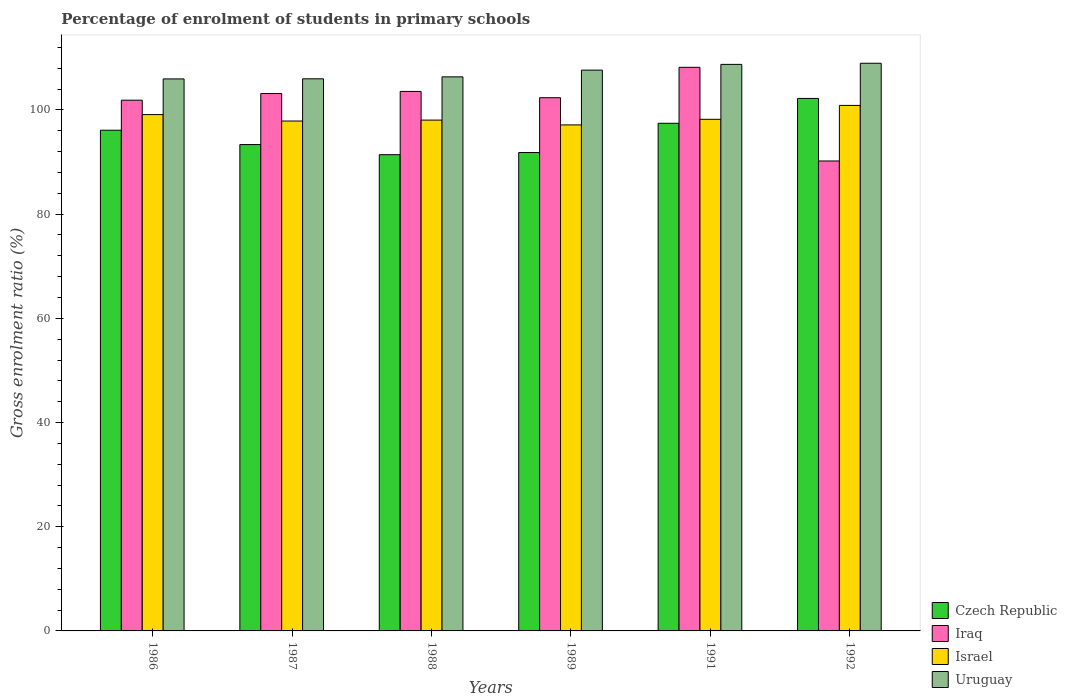How many different coloured bars are there?
Provide a succinct answer. 4. How many groups of bars are there?
Ensure brevity in your answer.  6. How many bars are there on the 5th tick from the left?
Provide a short and direct response. 4. How many bars are there on the 6th tick from the right?
Provide a short and direct response. 4. What is the label of the 2nd group of bars from the left?
Ensure brevity in your answer.  1987. In how many cases, is the number of bars for a given year not equal to the number of legend labels?
Offer a terse response. 0. What is the percentage of students enrolled in primary schools in Uruguay in 1987?
Offer a very short reply. 105.98. Across all years, what is the maximum percentage of students enrolled in primary schools in Uruguay?
Offer a terse response. 108.96. Across all years, what is the minimum percentage of students enrolled in primary schools in Uruguay?
Your response must be concise. 105.96. What is the total percentage of students enrolled in primary schools in Iraq in the graph?
Provide a short and direct response. 609.33. What is the difference between the percentage of students enrolled in primary schools in Iraq in 1986 and that in 1991?
Your response must be concise. -6.31. What is the difference between the percentage of students enrolled in primary schools in Israel in 1986 and the percentage of students enrolled in primary schools in Uruguay in 1989?
Make the answer very short. -8.53. What is the average percentage of students enrolled in primary schools in Uruguay per year?
Your answer should be compact. 107.28. In the year 1986, what is the difference between the percentage of students enrolled in primary schools in Iraq and percentage of students enrolled in primary schools in Czech Republic?
Your answer should be very brief. 5.76. In how many years, is the percentage of students enrolled in primary schools in Israel greater than 76 %?
Provide a short and direct response. 6. What is the ratio of the percentage of students enrolled in primary schools in Uruguay in 1988 to that in 1989?
Keep it short and to the point. 0.99. Is the difference between the percentage of students enrolled in primary schools in Iraq in 1987 and 1988 greater than the difference between the percentage of students enrolled in primary schools in Czech Republic in 1987 and 1988?
Provide a short and direct response. No. What is the difference between the highest and the second highest percentage of students enrolled in primary schools in Israel?
Offer a terse response. 1.76. What is the difference between the highest and the lowest percentage of students enrolled in primary schools in Iraq?
Offer a terse response. 17.98. Is it the case that in every year, the sum of the percentage of students enrolled in primary schools in Iraq and percentage of students enrolled in primary schools in Israel is greater than the sum of percentage of students enrolled in primary schools in Czech Republic and percentage of students enrolled in primary schools in Uruguay?
Make the answer very short. Yes. What does the 2nd bar from the right in 1986 represents?
Make the answer very short. Israel. Is it the case that in every year, the sum of the percentage of students enrolled in primary schools in Uruguay and percentage of students enrolled in primary schools in Iraq is greater than the percentage of students enrolled in primary schools in Israel?
Offer a very short reply. Yes. Are the values on the major ticks of Y-axis written in scientific E-notation?
Provide a succinct answer. No. Does the graph contain any zero values?
Offer a very short reply. No. How are the legend labels stacked?
Offer a very short reply. Vertical. What is the title of the graph?
Offer a terse response. Percentage of enrolment of students in primary schools. Does "Sri Lanka" appear as one of the legend labels in the graph?
Make the answer very short. No. What is the label or title of the X-axis?
Offer a terse response. Years. What is the label or title of the Y-axis?
Provide a succinct answer. Gross enrolment ratio (%). What is the Gross enrolment ratio (%) in Czech Republic in 1986?
Your response must be concise. 96.11. What is the Gross enrolment ratio (%) of Iraq in 1986?
Provide a succinct answer. 101.87. What is the Gross enrolment ratio (%) of Israel in 1986?
Ensure brevity in your answer.  99.11. What is the Gross enrolment ratio (%) of Uruguay in 1986?
Your answer should be compact. 105.96. What is the Gross enrolment ratio (%) in Czech Republic in 1987?
Offer a terse response. 93.36. What is the Gross enrolment ratio (%) of Iraq in 1987?
Provide a succinct answer. 103.16. What is the Gross enrolment ratio (%) of Israel in 1987?
Provide a short and direct response. 97.88. What is the Gross enrolment ratio (%) in Uruguay in 1987?
Your answer should be compact. 105.98. What is the Gross enrolment ratio (%) of Czech Republic in 1988?
Make the answer very short. 91.42. What is the Gross enrolment ratio (%) of Iraq in 1988?
Keep it short and to the point. 103.56. What is the Gross enrolment ratio (%) in Israel in 1988?
Make the answer very short. 98.05. What is the Gross enrolment ratio (%) in Uruguay in 1988?
Provide a short and direct response. 106.35. What is the Gross enrolment ratio (%) of Czech Republic in 1989?
Offer a very short reply. 91.83. What is the Gross enrolment ratio (%) of Iraq in 1989?
Your response must be concise. 102.35. What is the Gross enrolment ratio (%) of Israel in 1989?
Provide a succinct answer. 97.13. What is the Gross enrolment ratio (%) in Uruguay in 1989?
Offer a very short reply. 107.64. What is the Gross enrolment ratio (%) in Czech Republic in 1991?
Your answer should be very brief. 97.44. What is the Gross enrolment ratio (%) in Iraq in 1991?
Offer a terse response. 108.19. What is the Gross enrolment ratio (%) in Israel in 1991?
Make the answer very short. 98.21. What is the Gross enrolment ratio (%) in Uruguay in 1991?
Ensure brevity in your answer.  108.75. What is the Gross enrolment ratio (%) in Czech Republic in 1992?
Give a very brief answer. 102.21. What is the Gross enrolment ratio (%) of Iraq in 1992?
Keep it short and to the point. 90.21. What is the Gross enrolment ratio (%) in Israel in 1992?
Your response must be concise. 100.87. What is the Gross enrolment ratio (%) of Uruguay in 1992?
Keep it short and to the point. 108.96. Across all years, what is the maximum Gross enrolment ratio (%) of Czech Republic?
Keep it short and to the point. 102.21. Across all years, what is the maximum Gross enrolment ratio (%) of Iraq?
Offer a terse response. 108.19. Across all years, what is the maximum Gross enrolment ratio (%) in Israel?
Offer a terse response. 100.87. Across all years, what is the maximum Gross enrolment ratio (%) of Uruguay?
Give a very brief answer. 108.96. Across all years, what is the minimum Gross enrolment ratio (%) of Czech Republic?
Make the answer very short. 91.42. Across all years, what is the minimum Gross enrolment ratio (%) of Iraq?
Your response must be concise. 90.21. Across all years, what is the minimum Gross enrolment ratio (%) in Israel?
Provide a short and direct response. 97.13. Across all years, what is the minimum Gross enrolment ratio (%) of Uruguay?
Make the answer very short. 105.96. What is the total Gross enrolment ratio (%) of Czech Republic in the graph?
Your answer should be compact. 572.36. What is the total Gross enrolment ratio (%) in Iraq in the graph?
Give a very brief answer. 609.33. What is the total Gross enrolment ratio (%) of Israel in the graph?
Offer a very short reply. 591.25. What is the total Gross enrolment ratio (%) in Uruguay in the graph?
Your response must be concise. 643.65. What is the difference between the Gross enrolment ratio (%) in Czech Republic in 1986 and that in 1987?
Your answer should be very brief. 2.75. What is the difference between the Gross enrolment ratio (%) in Iraq in 1986 and that in 1987?
Your response must be concise. -1.28. What is the difference between the Gross enrolment ratio (%) in Israel in 1986 and that in 1987?
Ensure brevity in your answer.  1.23. What is the difference between the Gross enrolment ratio (%) in Uruguay in 1986 and that in 1987?
Your answer should be compact. -0.02. What is the difference between the Gross enrolment ratio (%) of Czech Republic in 1986 and that in 1988?
Provide a succinct answer. 4.69. What is the difference between the Gross enrolment ratio (%) of Iraq in 1986 and that in 1988?
Ensure brevity in your answer.  -1.68. What is the difference between the Gross enrolment ratio (%) of Israel in 1986 and that in 1988?
Make the answer very short. 1.06. What is the difference between the Gross enrolment ratio (%) in Uruguay in 1986 and that in 1988?
Provide a succinct answer. -0.39. What is the difference between the Gross enrolment ratio (%) of Czech Republic in 1986 and that in 1989?
Keep it short and to the point. 4.28. What is the difference between the Gross enrolment ratio (%) in Iraq in 1986 and that in 1989?
Your answer should be compact. -0.48. What is the difference between the Gross enrolment ratio (%) in Israel in 1986 and that in 1989?
Keep it short and to the point. 1.98. What is the difference between the Gross enrolment ratio (%) in Uruguay in 1986 and that in 1989?
Give a very brief answer. -1.68. What is the difference between the Gross enrolment ratio (%) in Czech Republic in 1986 and that in 1991?
Provide a succinct answer. -1.33. What is the difference between the Gross enrolment ratio (%) in Iraq in 1986 and that in 1991?
Your answer should be compact. -6.31. What is the difference between the Gross enrolment ratio (%) of Israel in 1986 and that in 1991?
Keep it short and to the point. 0.9. What is the difference between the Gross enrolment ratio (%) in Uruguay in 1986 and that in 1991?
Your response must be concise. -2.79. What is the difference between the Gross enrolment ratio (%) in Czech Republic in 1986 and that in 1992?
Your answer should be very brief. -6.1. What is the difference between the Gross enrolment ratio (%) of Iraq in 1986 and that in 1992?
Ensure brevity in your answer.  11.67. What is the difference between the Gross enrolment ratio (%) in Israel in 1986 and that in 1992?
Your answer should be very brief. -1.76. What is the difference between the Gross enrolment ratio (%) of Uruguay in 1986 and that in 1992?
Give a very brief answer. -3. What is the difference between the Gross enrolment ratio (%) of Czech Republic in 1987 and that in 1988?
Provide a succinct answer. 1.94. What is the difference between the Gross enrolment ratio (%) in Iraq in 1987 and that in 1988?
Give a very brief answer. -0.4. What is the difference between the Gross enrolment ratio (%) in Israel in 1987 and that in 1988?
Give a very brief answer. -0.18. What is the difference between the Gross enrolment ratio (%) of Uruguay in 1987 and that in 1988?
Give a very brief answer. -0.37. What is the difference between the Gross enrolment ratio (%) in Czech Republic in 1987 and that in 1989?
Ensure brevity in your answer.  1.53. What is the difference between the Gross enrolment ratio (%) of Iraq in 1987 and that in 1989?
Your response must be concise. 0.8. What is the difference between the Gross enrolment ratio (%) of Israel in 1987 and that in 1989?
Your answer should be compact. 0.75. What is the difference between the Gross enrolment ratio (%) of Uruguay in 1987 and that in 1989?
Make the answer very short. -1.66. What is the difference between the Gross enrolment ratio (%) in Czech Republic in 1987 and that in 1991?
Provide a succinct answer. -4.08. What is the difference between the Gross enrolment ratio (%) of Iraq in 1987 and that in 1991?
Make the answer very short. -5.03. What is the difference between the Gross enrolment ratio (%) in Israel in 1987 and that in 1991?
Provide a short and direct response. -0.33. What is the difference between the Gross enrolment ratio (%) of Uruguay in 1987 and that in 1991?
Give a very brief answer. -2.77. What is the difference between the Gross enrolment ratio (%) of Czech Republic in 1987 and that in 1992?
Offer a very short reply. -8.85. What is the difference between the Gross enrolment ratio (%) of Iraq in 1987 and that in 1992?
Provide a succinct answer. 12.95. What is the difference between the Gross enrolment ratio (%) in Israel in 1987 and that in 1992?
Make the answer very short. -2.99. What is the difference between the Gross enrolment ratio (%) of Uruguay in 1987 and that in 1992?
Your response must be concise. -2.98. What is the difference between the Gross enrolment ratio (%) of Czech Republic in 1988 and that in 1989?
Offer a terse response. -0.41. What is the difference between the Gross enrolment ratio (%) in Iraq in 1988 and that in 1989?
Provide a short and direct response. 1.2. What is the difference between the Gross enrolment ratio (%) of Israel in 1988 and that in 1989?
Your response must be concise. 0.92. What is the difference between the Gross enrolment ratio (%) in Uruguay in 1988 and that in 1989?
Provide a succinct answer. -1.29. What is the difference between the Gross enrolment ratio (%) of Czech Republic in 1988 and that in 1991?
Ensure brevity in your answer.  -6.03. What is the difference between the Gross enrolment ratio (%) of Iraq in 1988 and that in 1991?
Provide a succinct answer. -4.63. What is the difference between the Gross enrolment ratio (%) of Israel in 1988 and that in 1991?
Your response must be concise. -0.15. What is the difference between the Gross enrolment ratio (%) in Uruguay in 1988 and that in 1991?
Your answer should be compact. -2.4. What is the difference between the Gross enrolment ratio (%) of Czech Republic in 1988 and that in 1992?
Offer a very short reply. -10.8. What is the difference between the Gross enrolment ratio (%) of Iraq in 1988 and that in 1992?
Offer a very short reply. 13.35. What is the difference between the Gross enrolment ratio (%) in Israel in 1988 and that in 1992?
Make the answer very short. -2.82. What is the difference between the Gross enrolment ratio (%) in Uruguay in 1988 and that in 1992?
Give a very brief answer. -2.61. What is the difference between the Gross enrolment ratio (%) in Czech Republic in 1989 and that in 1991?
Make the answer very short. -5.61. What is the difference between the Gross enrolment ratio (%) of Iraq in 1989 and that in 1991?
Make the answer very short. -5.83. What is the difference between the Gross enrolment ratio (%) of Israel in 1989 and that in 1991?
Your response must be concise. -1.08. What is the difference between the Gross enrolment ratio (%) of Uruguay in 1989 and that in 1991?
Give a very brief answer. -1.1. What is the difference between the Gross enrolment ratio (%) of Czech Republic in 1989 and that in 1992?
Make the answer very short. -10.38. What is the difference between the Gross enrolment ratio (%) of Iraq in 1989 and that in 1992?
Make the answer very short. 12.15. What is the difference between the Gross enrolment ratio (%) in Israel in 1989 and that in 1992?
Your answer should be compact. -3.74. What is the difference between the Gross enrolment ratio (%) of Uruguay in 1989 and that in 1992?
Offer a terse response. -1.32. What is the difference between the Gross enrolment ratio (%) in Czech Republic in 1991 and that in 1992?
Make the answer very short. -4.77. What is the difference between the Gross enrolment ratio (%) in Iraq in 1991 and that in 1992?
Your response must be concise. 17.98. What is the difference between the Gross enrolment ratio (%) of Israel in 1991 and that in 1992?
Provide a short and direct response. -2.67. What is the difference between the Gross enrolment ratio (%) in Uruguay in 1991 and that in 1992?
Provide a succinct answer. -0.22. What is the difference between the Gross enrolment ratio (%) in Czech Republic in 1986 and the Gross enrolment ratio (%) in Iraq in 1987?
Provide a succinct answer. -7.05. What is the difference between the Gross enrolment ratio (%) of Czech Republic in 1986 and the Gross enrolment ratio (%) of Israel in 1987?
Keep it short and to the point. -1.77. What is the difference between the Gross enrolment ratio (%) of Czech Republic in 1986 and the Gross enrolment ratio (%) of Uruguay in 1987?
Your answer should be very brief. -9.87. What is the difference between the Gross enrolment ratio (%) of Iraq in 1986 and the Gross enrolment ratio (%) of Israel in 1987?
Provide a succinct answer. 4. What is the difference between the Gross enrolment ratio (%) of Iraq in 1986 and the Gross enrolment ratio (%) of Uruguay in 1987?
Keep it short and to the point. -4.11. What is the difference between the Gross enrolment ratio (%) of Israel in 1986 and the Gross enrolment ratio (%) of Uruguay in 1987?
Make the answer very short. -6.87. What is the difference between the Gross enrolment ratio (%) in Czech Republic in 1986 and the Gross enrolment ratio (%) in Iraq in 1988?
Offer a very short reply. -7.45. What is the difference between the Gross enrolment ratio (%) in Czech Republic in 1986 and the Gross enrolment ratio (%) in Israel in 1988?
Offer a very short reply. -1.94. What is the difference between the Gross enrolment ratio (%) in Czech Republic in 1986 and the Gross enrolment ratio (%) in Uruguay in 1988?
Offer a terse response. -10.24. What is the difference between the Gross enrolment ratio (%) in Iraq in 1986 and the Gross enrolment ratio (%) in Israel in 1988?
Offer a very short reply. 3.82. What is the difference between the Gross enrolment ratio (%) of Iraq in 1986 and the Gross enrolment ratio (%) of Uruguay in 1988?
Make the answer very short. -4.48. What is the difference between the Gross enrolment ratio (%) in Israel in 1986 and the Gross enrolment ratio (%) in Uruguay in 1988?
Keep it short and to the point. -7.24. What is the difference between the Gross enrolment ratio (%) of Czech Republic in 1986 and the Gross enrolment ratio (%) of Iraq in 1989?
Provide a short and direct response. -6.24. What is the difference between the Gross enrolment ratio (%) of Czech Republic in 1986 and the Gross enrolment ratio (%) of Israel in 1989?
Your answer should be very brief. -1.02. What is the difference between the Gross enrolment ratio (%) in Czech Republic in 1986 and the Gross enrolment ratio (%) in Uruguay in 1989?
Ensure brevity in your answer.  -11.54. What is the difference between the Gross enrolment ratio (%) in Iraq in 1986 and the Gross enrolment ratio (%) in Israel in 1989?
Provide a short and direct response. 4.74. What is the difference between the Gross enrolment ratio (%) of Iraq in 1986 and the Gross enrolment ratio (%) of Uruguay in 1989?
Ensure brevity in your answer.  -5.77. What is the difference between the Gross enrolment ratio (%) in Israel in 1986 and the Gross enrolment ratio (%) in Uruguay in 1989?
Ensure brevity in your answer.  -8.53. What is the difference between the Gross enrolment ratio (%) in Czech Republic in 1986 and the Gross enrolment ratio (%) in Iraq in 1991?
Your answer should be very brief. -12.08. What is the difference between the Gross enrolment ratio (%) of Czech Republic in 1986 and the Gross enrolment ratio (%) of Israel in 1991?
Keep it short and to the point. -2.1. What is the difference between the Gross enrolment ratio (%) in Czech Republic in 1986 and the Gross enrolment ratio (%) in Uruguay in 1991?
Make the answer very short. -12.64. What is the difference between the Gross enrolment ratio (%) in Iraq in 1986 and the Gross enrolment ratio (%) in Israel in 1991?
Offer a terse response. 3.67. What is the difference between the Gross enrolment ratio (%) of Iraq in 1986 and the Gross enrolment ratio (%) of Uruguay in 1991?
Provide a short and direct response. -6.88. What is the difference between the Gross enrolment ratio (%) in Israel in 1986 and the Gross enrolment ratio (%) in Uruguay in 1991?
Make the answer very short. -9.64. What is the difference between the Gross enrolment ratio (%) of Czech Republic in 1986 and the Gross enrolment ratio (%) of Iraq in 1992?
Give a very brief answer. 5.9. What is the difference between the Gross enrolment ratio (%) of Czech Republic in 1986 and the Gross enrolment ratio (%) of Israel in 1992?
Provide a succinct answer. -4.76. What is the difference between the Gross enrolment ratio (%) in Czech Republic in 1986 and the Gross enrolment ratio (%) in Uruguay in 1992?
Your answer should be very brief. -12.86. What is the difference between the Gross enrolment ratio (%) in Iraq in 1986 and the Gross enrolment ratio (%) in Uruguay in 1992?
Your response must be concise. -7.09. What is the difference between the Gross enrolment ratio (%) of Israel in 1986 and the Gross enrolment ratio (%) of Uruguay in 1992?
Make the answer very short. -9.85. What is the difference between the Gross enrolment ratio (%) of Czech Republic in 1987 and the Gross enrolment ratio (%) of Iraq in 1988?
Offer a terse response. -10.2. What is the difference between the Gross enrolment ratio (%) in Czech Republic in 1987 and the Gross enrolment ratio (%) in Israel in 1988?
Your answer should be compact. -4.7. What is the difference between the Gross enrolment ratio (%) in Czech Republic in 1987 and the Gross enrolment ratio (%) in Uruguay in 1988?
Offer a terse response. -12.99. What is the difference between the Gross enrolment ratio (%) of Iraq in 1987 and the Gross enrolment ratio (%) of Israel in 1988?
Provide a short and direct response. 5.1. What is the difference between the Gross enrolment ratio (%) in Iraq in 1987 and the Gross enrolment ratio (%) in Uruguay in 1988?
Your answer should be compact. -3.2. What is the difference between the Gross enrolment ratio (%) in Israel in 1987 and the Gross enrolment ratio (%) in Uruguay in 1988?
Keep it short and to the point. -8.47. What is the difference between the Gross enrolment ratio (%) of Czech Republic in 1987 and the Gross enrolment ratio (%) of Iraq in 1989?
Keep it short and to the point. -8.99. What is the difference between the Gross enrolment ratio (%) of Czech Republic in 1987 and the Gross enrolment ratio (%) of Israel in 1989?
Your response must be concise. -3.77. What is the difference between the Gross enrolment ratio (%) of Czech Republic in 1987 and the Gross enrolment ratio (%) of Uruguay in 1989?
Offer a terse response. -14.29. What is the difference between the Gross enrolment ratio (%) in Iraq in 1987 and the Gross enrolment ratio (%) in Israel in 1989?
Give a very brief answer. 6.03. What is the difference between the Gross enrolment ratio (%) of Iraq in 1987 and the Gross enrolment ratio (%) of Uruguay in 1989?
Your response must be concise. -4.49. What is the difference between the Gross enrolment ratio (%) in Israel in 1987 and the Gross enrolment ratio (%) in Uruguay in 1989?
Offer a terse response. -9.77. What is the difference between the Gross enrolment ratio (%) in Czech Republic in 1987 and the Gross enrolment ratio (%) in Iraq in 1991?
Your response must be concise. -14.83. What is the difference between the Gross enrolment ratio (%) of Czech Republic in 1987 and the Gross enrolment ratio (%) of Israel in 1991?
Ensure brevity in your answer.  -4.85. What is the difference between the Gross enrolment ratio (%) in Czech Republic in 1987 and the Gross enrolment ratio (%) in Uruguay in 1991?
Ensure brevity in your answer.  -15.39. What is the difference between the Gross enrolment ratio (%) in Iraq in 1987 and the Gross enrolment ratio (%) in Israel in 1991?
Offer a very short reply. 4.95. What is the difference between the Gross enrolment ratio (%) of Iraq in 1987 and the Gross enrolment ratio (%) of Uruguay in 1991?
Offer a terse response. -5.59. What is the difference between the Gross enrolment ratio (%) of Israel in 1987 and the Gross enrolment ratio (%) of Uruguay in 1991?
Provide a short and direct response. -10.87. What is the difference between the Gross enrolment ratio (%) in Czech Republic in 1987 and the Gross enrolment ratio (%) in Iraq in 1992?
Give a very brief answer. 3.15. What is the difference between the Gross enrolment ratio (%) of Czech Republic in 1987 and the Gross enrolment ratio (%) of Israel in 1992?
Give a very brief answer. -7.51. What is the difference between the Gross enrolment ratio (%) in Czech Republic in 1987 and the Gross enrolment ratio (%) in Uruguay in 1992?
Ensure brevity in your answer.  -15.61. What is the difference between the Gross enrolment ratio (%) of Iraq in 1987 and the Gross enrolment ratio (%) of Israel in 1992?
Your answer should be compact. 2.28. What is the difference between the Gross enrolment ratio (%) of Iraq in 1987 and the Gross enrolment ratio (%) of Uruguay in 1992?
Provide a short and direct response. -5.81. What is the difference between the Gross enrolment ratio (%) in Israel in 1987 and the Gross enrolment ratio (%) in Uruguay in 1992?
Your response must be concise. -11.09. What is the difference between the Gross enrolment ratio (%) in Czech Republic in 1988 and the Gross enrolment ratio (%) in Iraq in 1989?
Keep it short and to the point. -10.94. What is the difference between the Gross enrolment ratio (%) in Czech Republic in 1988 and the Gross enrolment ratio (%) in Israel in 1989?
Make the answer very short. -5.72. What is the difference between the Gross enrolment ratio (%) of Czech Republic in 1988 and the Gross enrolment ratio (%) of Uruguay in 1989?
Make the answer very short. -16.23. What is the difference between the Gross enrolment ratio (%) in Iraq in 1988 and the Gross enrolment ratio (%) in Israel in 1989?
Give a very brief answer. 6.43. What is the difference between the Gross enrolment ratio (%) of Iraq in 1988 and the Gross enrolment ratio (%) of Uruguay in 1989?
Make the answer very short. -4.09. What is the difference between the Gross enrolment ratio (%) in Israel in 1988 and the Gross enrolment ratio (%) in Uruguay in 1989?
Your response must be concise. -9.59. What is the difference between the Gross enrolment ratio (%) in Czech Republic in 1988 and the Gross enrolment ratio (%) in Iraq in 1991?
Give a very brief answer. -16.77. What is the difference between the Gross enrolment ratio (%) of Czech Republic in 1988 and the Gross enrolment ratio (%) of Israel in 1991?
Give a very brief answer. -6.79. What is the difference between the Gross enrolment ratio (%) in Czech Republic in 1988 and the Gross enrolment ratio (%) in Uruguay in 1991?
Your answer should be compact. -17.33. What is the difference between the Gross enrolment ratio (%) in Iraq in 1988 and the Gross enrolment ratio (%) in Israel in 1991?
Your answer should be very brief. 5.35. What is the difference between the Gross enrolment ratio (%) of Iraq in 1988 and the Gross enrolment ratio (%) of Uruguay in 1991?
Offer a terse response. -5.19. What is the difference between the Gross enrolment ratio (%) of Israel in 1988 and the Gross enrolment ratio (%) of Uruguay in 1991?
Provide a succinct answer. -10.7. What is the difference between the Gross enrolment ratio (%) of Czech Republic in 1988 and the Gross enrolment ratio (%) of Iraq in 1992?
Your answer should be very brief. 1.21. What is the difference between the Gross enrolment ratio (%) in Czech Republic in 1988 and the Gross enrolment ratio (%) in Israel in 1992?
Provide a short and direct response. -9.46. What is the difference between the Gross enrolment ratio (%) of Czech Republic in 1988 and the Gross enrolment ratio (%) of Uruguay in 1992?
Offer a very short reply. -17.55. What is the difference between the Gross enrolment ratio (%) of Iraq in 1988 and the Gross enrolment ratio (%) of Israel in 1992?
Your response must be concise. 2.68. What is the difference between the Gross enrolment ratio (%) in Iraq in 1988 and the Gross enrolment ratio (%) in Uruguay in 1992?
Provide a succinct answer. -5.41. What is the difference between the Gross enrolment ratio (%) of Israel in 1988 and the Gross enrolment ratio (%) of Uruguay in 1992?
Offer a very short reply. -10.91. What is the difference between the Gross enrolment ratio (%) in Czech Republic in 1989 and the Gross enrolment ratio (%) in Iraq in 1991?
Offer a terse response. -16.36. What is the difference between the Gross enrolment ratio (%) in Czech Republic in 1989 and the Gross enrolment ratio (%) in Israel in 1991?
Keep it short and to the point. -6.38. What is the difference between the Gross enrolment ratio (%) of Czech Republic in 1989 and the Gross enrolment ratio (%) of Uruguay in 1991?
Your response must be concise. -16.92. What is the difference between the Gross enrolment ratio (%) of Iraq in 1989 and the Gross enrolment ratio (%) of Israel in 1991?
Provide a short and direct response. 4.15. What is the difference between the Gross enrolment ratio (%) in Iraq in 1989 and the Gross enrolment ratio (%) in Uruguay in 1991?
Keep it short and to the point. -6.4. What is the difference between the Gross enrolment ratio (%) of Israel in 1989 and the Gross enrolment ratio (%) of Uruguay in 1991?
Your answer should be compact. -11.62. What is the difference between the Gross enrolment ratio (%) of Czech Republic in 1989 and the Gross enrolment ratio (%) of Iraq in 1992?
Your response must be concise. 1.62. What is the difference between the Gross enrolment ratio (%) in Czech Republic in 1989 and the Gross enrolment ratio (%) in Israel in 1992?
Provide a succinct answer. -9.04. What is the difference between the Gross enrolment ratio (%) of Czech Republic in 1989 and the Gross enrolment ratio (%) of Uruguay in 1992?
Keep it short and to the point. -17.14. What is the difference between the Gross enrolment ratio (%) in Iraq in 1989 and the Gross enrolment ratio (%) in Israel in 1992?
Give a very brief answer. 1.48. What is the difference between the Gross enrolment ratio (%) of Iraq in 1989 and the Gross enrolment ratio (%) of Uruguay in 1992?
Ensure brevity in your answer.  -6.61. What is the difference between the Gross enrolment ratio (%) of Israel in 1989 and the Gross enrolment ratio (%) of Uruguay in 1992?
Give a very brief answer. -11.83. What is the difference between the Gross enrolment ratio (%) in Czech Republic in 1991 and the Gross enrolment ratio (%) in Iraq in 1992?
Keep it short and to the point. 7.24. What is the difference between the Gross enrolment ratio (%) of Czech Republic in 1991 and the Gross enrolment ratio (%) of Israel in 1992?
Provide a succinct answer. -3.43. What is the difference between the Gross enrolment ratio (%) in Czech Republic in 1991 and the Gross enrolment ratio (%) in Uruguay in 1992?
Ensure brevity in your answer.  -11.52. What is the difference between the Gross enrolment ratio (%) in Iraq in 1991 and the Gross enrolment ratio (%) in Israel in 1992?
Offer a very short reply. 7.31. What is the difference between the Gross enrolment ratio (%) in Iraq in 1991 and the Gross enrolment ratio (%) in Uruguay in 1992?
Your answer should be compact. -0.78. What is the difference between the Gross enrolment ratio (%) of Israel in 1991 and the Gross enrolment ratio (%) of Uruguay in 1992?
Your answer should be very brief. -10.76. What is the average Gross enrolment ratio (%) in Czech Republic per year?
Your answer should be compact. 95.39. What is the average Gross enrolment ratio (%) in Iraq per year?
Your answer should be very brief. 101.56. What is the average Gross enrolment ratio (%) of Israel per year?
Provide a short and direct response. 98.54. What is the average Gross enrolment ratio (%) in Uruguay per year?
Give a very brief answer. 107.28. In the year 1986, what is the difference between the Gross enrolment ratio (%) of Czech Republic and Gross enrolment ratio (%) of Iraq?
Provide a succinct answer. -5.76. In the year 1986, what is the difference between the Gross enrolment ratio (%) in Czech Republic and Gross enrolment ratio (%) in Israel?
Your response must be concise. -3. In the year 1986, what is the difference between the Gross enrolment ratio (%) in Czech Republic and Gross enrolment ratio (%) in Uruguay?
Offer a terse response. -9.85. In the year 1986, what is the difference between the Gross enrolment ratio (%) of Iraq and Gross enrolment ratio (%) of Israel?
Keep it short and to the point. 2.76. In the year 1986, what is the difference between the Gross enrolment ratio (%) of Iraq and Gross enrolment ratio (%) of Uruguay?
Provide a succinct answer. -4.09. In the year 1986, what is the difference between the Gross enrolment ratio (%) of Israel and Gross enrolment ratio (%) of Uruguay?
Ensure brevity in your answer.  -6.85. In the year 1987, what is the difference between the Gross enrolment ratio (%) of Czech Republic and Gross enrolment ratio (%) of Iraq?
Make the answer very short. -9.8. In the year 1987, what is the difference between the Gross enrolment ratio (%) in Czech Republic and Gross enrolment ratio (%) in Israel?
Make the answer very short. -4.52. In the year 1987, what is the difference between the Gross enrolment ratio (%) of Czech Republic and Gross enrolment ratio (%) of Uruguay?
Your answer should be compact. -12.62. In the year 1987, what is the difference between the Gross enrolment ratio (%) of Iraq and Gross enrolment ratio (%) of Israel?
Offer a terse response. 5.28. In the year 1987, what is the difference between the Gross enrolment ratio (%) of Iraq and Gross enrolment ratio (%) of Uruguay?
Your response must be concise. -2.83. In the year 1987, what is the difference between the Gross enrolment ratio (%) of Israel and Gross enrolment ratio (%) of Uruguay?
Offer a terse response. -8.1. In the year 1988, what is the difference between the Gross enrolment ratio (%) of Czech Republic and Gross enrolment ratio (%) of Iraq?
Give a very brief answer. -12.14. In the year 1988, what is the difference between the Gross enrolment ratio (%) of Czech Republic and Gross enrolment ratio (%) of Israel?
Provide a succinct answer. -6.64. In the year 1988, what is the difference between the Gross enrolment ratio (%) in Czech Republic and Gross enrolment ratio (%) in Uruguay?
Offer a terse response. -14.94. In the year 1988, what is the difference between the Gross enrolment ratio (%) of Iraq and Gross enrolment ratio (%) of Israel?
Ensure brevity in your answer.  5.5. In the year 1988, what is the difference between the Gross enrolment ratio (%) in Iraq and Gross enrolment ratio (%) in Uruguay?
Your answer should be compact. -2.79. In the year 1988, what is the difference between the Gross enrolment ratio (%) in Israel and Gross enrolment ratio (%) in Uruguay?
Give a very brief answer. -8.3. In the year 1989, what is the difference between the Gross enrolment ratio (%) of Czech Republic and Gross enrolment ratio (%) of Iraq?
Offer a very short reply. -10.52. In the year 1989, what is the difference between the Gross enrolment ratio (%) in Czech Republic and Gross enrolment ratio (%) in Israel?
Your response must be concise. -5.3. In the year 1989, what is the difference between the Gross enrolment ratio (%) of Czech Republic and Gross enrolment ratio (%) of Uruguay?
Your response must be concise. -15.82. In the year 1989, what is the difference between the Gross enrolment ratio (%) in Iraq and Gross enrolment ratio (%) in Israel?
Keep it short and to the point. 5.22. In the year 1989, what is the difference between the Gross enrolment ratio (%) in Iraq and Gross enrolment ratio (%) in Uruguay?
Keep it short and to the point. -5.29. In the year 1989, what is the difference between the Gross enrolment ratio (%) of Israel and Gross enrolment ratio (%) of Uruguay?
Ensure brevity in your answer.  -10.51. In the year 1991, what is the difference between the Gross enrolment ratio (%) of Czech Republic and Gross enrolment ratio (%) of Iraq?
Provide a short and direct response. -10.74. In the year 1991, what is the difference between the Gross enrolment ratio (%) in Czech Republic and Gross enrolment ratio (%) in Israel?
Offer a terse response. -0.77. In the year 1991, what is the difference between the Gross enrolment ratio (%) in Czech Republic and Gross enrolment ratio (%) in Uruguay?
Your response must be concise. -11.31. In the year 1991, what is the difference between the Gross enrolment ratio (%) of Iraq and Gross enrolment ratio (%) of Israel?
Your answer should be compact. 9.98. In the year 1991, what is the difference between the Gross enrolment ratio (%) of Iraq and Gross enrolment ratio (%) of Uruguay?
Offer a terse response. -0.56. In the year 1991, what is the difference between the Gross enrolment ratio (%) of Israel and Gross enrolment ratio (%) of Uruguay?
Provide a succinct answer. -10.54. In the year 1992, what is the difference between the Gross enrolment ratio (%) of Czech Republic and Gross enrolment ratio (%) of Iraq?
Your response must be concise. 12.01. In the year 1992, what is the difference between the Gross enrolment ratio (%) of Czech Republic and Gross enrolment ratio (%) of Israel?
Keep it short and to the point. 1.34. In the year 1992, what is the difference between the Gross enrolment ratio (%) in Czech Republic and Gross enrolment ratio (%) in Uruguay?
Your answer should be very brief. -6.75. In the year 1992, what is the difference between the Gross enrolment ratio (%) in Iraq and Gross enrolment ratio (%) in Israel?
Provide a short and direct response. -10.67. In the year 1992, what is the difference between the Gross enrolment ratio (%) in Iraq and Gross enrolment ratio (%) in Uruguay?
Your answer should be very brief. -18.76. In the year 1992, what is the difference between the Gross enrolment ratio (%) of Israel and Gross enrolment ratio (%) of Uruguay?
Your response must be concise. -8.09. What is the ratio of the Gross enrolment ratio (%) in Czech Republic in 1986 to that in 1987?
Give a very brief answer. 1.03. What is the ratio of the Gross enrolment ratio (%) of Iraq in 1986 to that in 1987?
Provide a short and direct response. 0.99. What is the ratio of the Gross enrolment ratio (%) of Israel in 1986 to that in 1987?
Ensure brevity in your answer.  1.01. What is the ratio of the Gross enrolment ratio (%) of Czech Republic in 1986 to that in 1988?
Offer a terse response. 1.05. What is the ratio of the Gross enrolment ratio (%) of Iraq in 1986 to that in 1988?
Your answer should be compact. 0.98. What is the ratio of the Gross enrolment ratio (%) of Israel in 1986 to that in 1988?
Your answer should be very brief. 1.01. What is the ratio of the Gross enrolment ratio (%) in Czech Republic in 1986 to that in 1989?
Your response must be concise. 1.05. What is the ratio of the Gross enrolment ratio (%) in Iraq in 1986 to that in 1989?
Keep it short and to the point. 1. What is the ratio of the Gross enrolment ratio (%) of Israel in 1986 to that in 1989?
Your answer should be compact. 1.02. What is the ratio of the Gross enrolment ratio (%) in Uruguay in 1986 to that in 1989?
Provide a short and direct response. 0.98. What is the ratio of the Gross enrolment ratio (%) of Czech Republic in 1986 to that in 1991?
Your answer should be compact. 0.99. What is the ratio of the Gross enrolment ratio (%) in Iraq in 1986 to that in 1991?
Provide a succinct answer. 0.94. What is the ratio of the Gross enrolment ratio (%) in Israel in 1986 to that in 1991?
Provide a succinct answer. 1.01. What is the ratio of the Gross enrolment ratio (%) of Uruguay in 1986 to that in 1991?
Keep it short and to the point. 0.97. What is the ratio of the Gross enrolment ratio (%) in Czech Republic in 1986 to that in 1992?
Provide a succinct answer. 0.94. What is the ratio of the Gross enrolment ratio (%) in Iraq in 1986 to that in 1992?
Ensure brevity in your answer.  1.13. What is the ratio of the Gross enrolment ratio (%) of Israel in 1986 to that in 1992?
Your answer should be compact. 0.98. What is the ratio of the Gross enrolment ratio (%) in Uruguay in 1986 to that in 1992?
Your answer should be compact. 0.97. What is the ratio of the Gross enrolment ratio (%) in Czech Republic in 1987 to that in 1988?
Offer a terse response. 1.02. What is the ratio of the Gross enrolment ratio (%) of Uruguay in 1987 to that in 1988?
Keep it short and to the point. 1. What is the ratio of the Gross enrolment ratio (%) of Czech Republic in 1987 to that in 1989?
Your answer should be very brief. 1.02. What is the ratio of the Gross enrolment ratio (%) of Iraq in 1987 to that in 1989?
Provide a short and direct response. 1.01. What is the ratio of the Gross enrolment ratio (%) in Israel in 1987 to that in 1989?
Give a very brief answer. 1.01. What is the ratio of the Gross enrolment ratio (%) of Uruguay in 1987 to that in 1989?
Your answer should be very brief. 0.98. What is the ratio of the Gross enrolment ratio (%) of Czech Republic in 1987 to that in 1991?
Provide a short and direct response. 0.96. What is the ratio of the Gross enrolment ratio (%) of Iraq in 1987 to that in 1991?
Offer a terse response. 0.95. What is the ratio of the Gross enrolment ratio (%) in Uruguay in 1987 to that in 1991?
Your answer should be very brief. 0.97. What is the ratio of the Gross enrolment ratio (%) in Czech Republic in 1987 to that in 1992?
Your answer should be compact. 0.91. What is the ratio of the Gross enrolment ratio (%) of Iraq in 1987 to that in 1992?
Offer a very short reply. 1.14. What is the ratio of the Gross enrolment ratio (%) of Israel in 1987 to that in 1992?
Ensure brevity in your answer.  0.97. What is the ratio of the Gross enrolment ratio (%) of Uruguay in 1987 to that in 1992?
Your answer should be very brief. 0.97. What is the ratio of the Gross enrolment ratio (%) in Czech Republic in 1988 to that in 1989?
Your answer should be very brief. 1. What is the ratio of the Gross enrolment ratio (%) in Iraq in 1988 to that in 1989?
Give a very brief answer. 1.01. What is the ratio of the Gross enrolment ratio (%) of Israel in 1988 to that in 1989?
Give a very brief answer. 1.01. What is the ratio of the Gross enrolment ratio (%) of Czech Republic in 1988 to that in 1991?
Your answer should be very brief. 0.94. What is the ratio of the Gross enrolment ratio (%) of Iraq in 1988 to that in 1991?
Provide a short and direct response. 0.96. What is the ratio of the Gross enrolment ratio (%) in Israel in 1988 to that in 1991?
Provide a short and direct response. 1. What is the ratio of the Gross enrolment ratio (%) of Czech Republic in 1988 to that in 1992?
Provide a succinct answer. 0.89. What is the ratio of the Gross enrolment ratio (%) of Iraq in 1988 to that in 1992?
Your answer should be very brief. 1.15. What is the ratio of the Gross enrolment ratio (%) of Israel in 1988 to that in 1992?
Make the answer very short. 0.97. What is the ratio of the Gross enrolment ratio (%) of Czech Republic in 1989 to that in 1991?
Your response must be concise. 0.94. What is the ratio of the Gross enrolment ratio (%) in Iraq in 1989 to that in 1991?
Offer a very short reply. 0.95. What is the ratio of the Gross enrolment ratio (%) of Czech Republic in 1989 to that in 1992?
Offer a very short reply. 0.9. What is the ratio of the Gross enrolment ratio (%) in Iraq in 1989 to that in 1992?
Offer a terse response. 1.13. What is the ratio of the Gross enrolment ratio (%) of Israel in 1989 to that in 1992?
Keep it short and to the point. 0.96. What is the ratio of the Gross enrolment ratio (%) of Uruguay in 1989 to that in 1992?
Provide a succinct answer. 0.99. What is the ratio of the Gross enrolment ratio (%) in Czech Republic in 1991 to that in 1992?
Your response must be concise. 0.95. What is the ratio of the Gross enrolment ratio (%) of Iraq in 1991 to that in 1992?
Your answer should be very brief. 1.2. What is the ratio of the Gross enrolment ratio (%) of Israel in 1991 to that in 1992?
Give a very brief answer. 0.97. What is the ratio of the Gross enrolment ratio (%) of Uruguay in 1991 to that in 1992?
Your response must be concise. 1. What is the difference between the highest and the second highest Gross enrolment ratio (%) in Czech Republic?
Give a very brief answer. 4.77. What is the difference between the highest and the second highest Gross enrolment ratio (%) of Iraq?
Provide a succinct answer. 4.63. What is the difference between the highest and the second highest Gross enrolment ratio (%) of Israel?
Your answer should be very brief. 1.76. What is the difference between the highest and the second highest Gross enrolment ratio (%) of Uruguay?
Provide a short and direct response. 0.22. What is the difference between the highest and the lowest Gross enrolment ratio (%) of Czech Republic?
Offer a terse response. 10.8. What is the difference between the highest and the lowest Gross enrolment ratio (%) of Iraq?
Offer a very short reply. 17.98. What is the difference between the highest and the lowest Gross enrolment ratio (%) in Israel?
Ensure brevity in your answer.  3.74. What is the difference between the highest and the lowest Gross enrolment ratio (%) of Uruguay?
Offer a terse response. 3. 